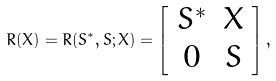<formula> <loc_0><loc_0><loc_500><loc_500>R ( X ) = R ( S ^ { * } , S ; X ) = \left [ \begin{array} { c c } S ^ { * } & X \\ 0 & S \end{array} \right ] ,</formula> 